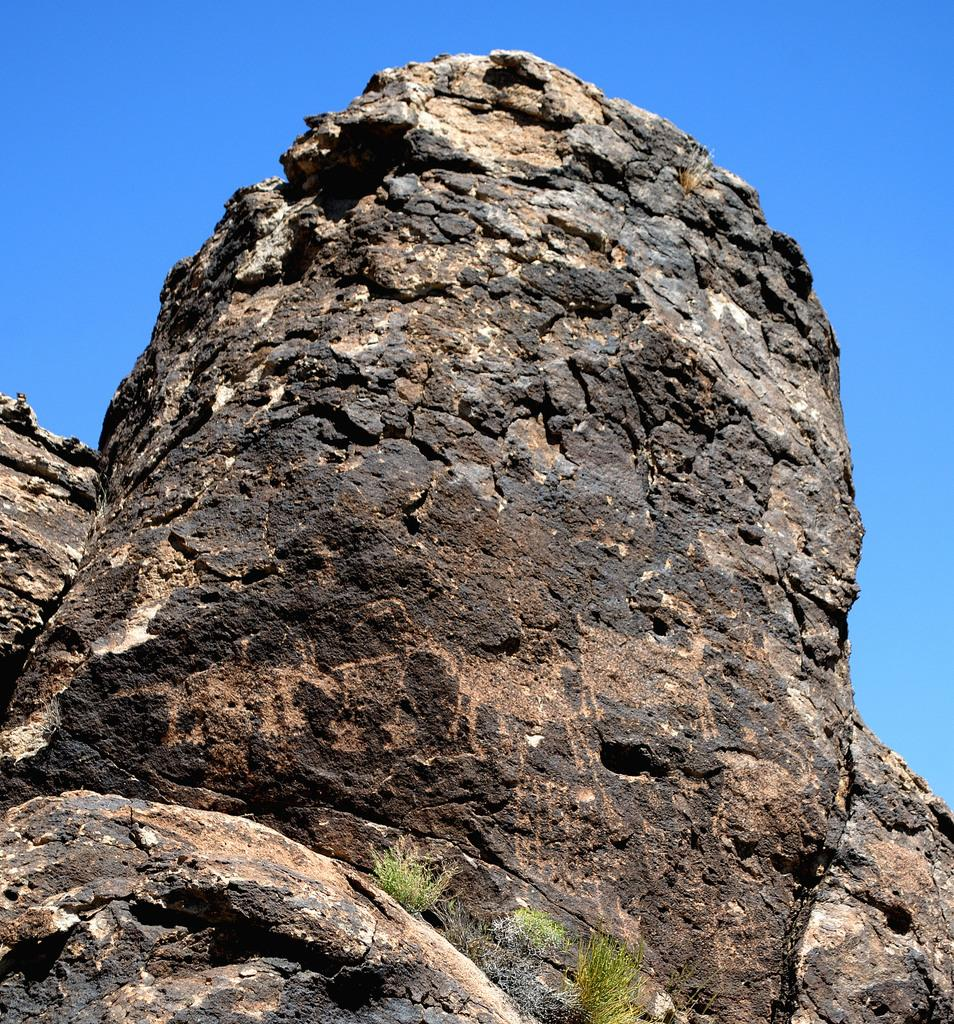What is the main subject of the image? There is a rock in the center of the image. What type of hen is sitting on the rock in the image? There is no hen present in the image; it only features a rock. What type of spade is being used by the judge in the image? There is no judge or spade present in the image; it only features a rock. 